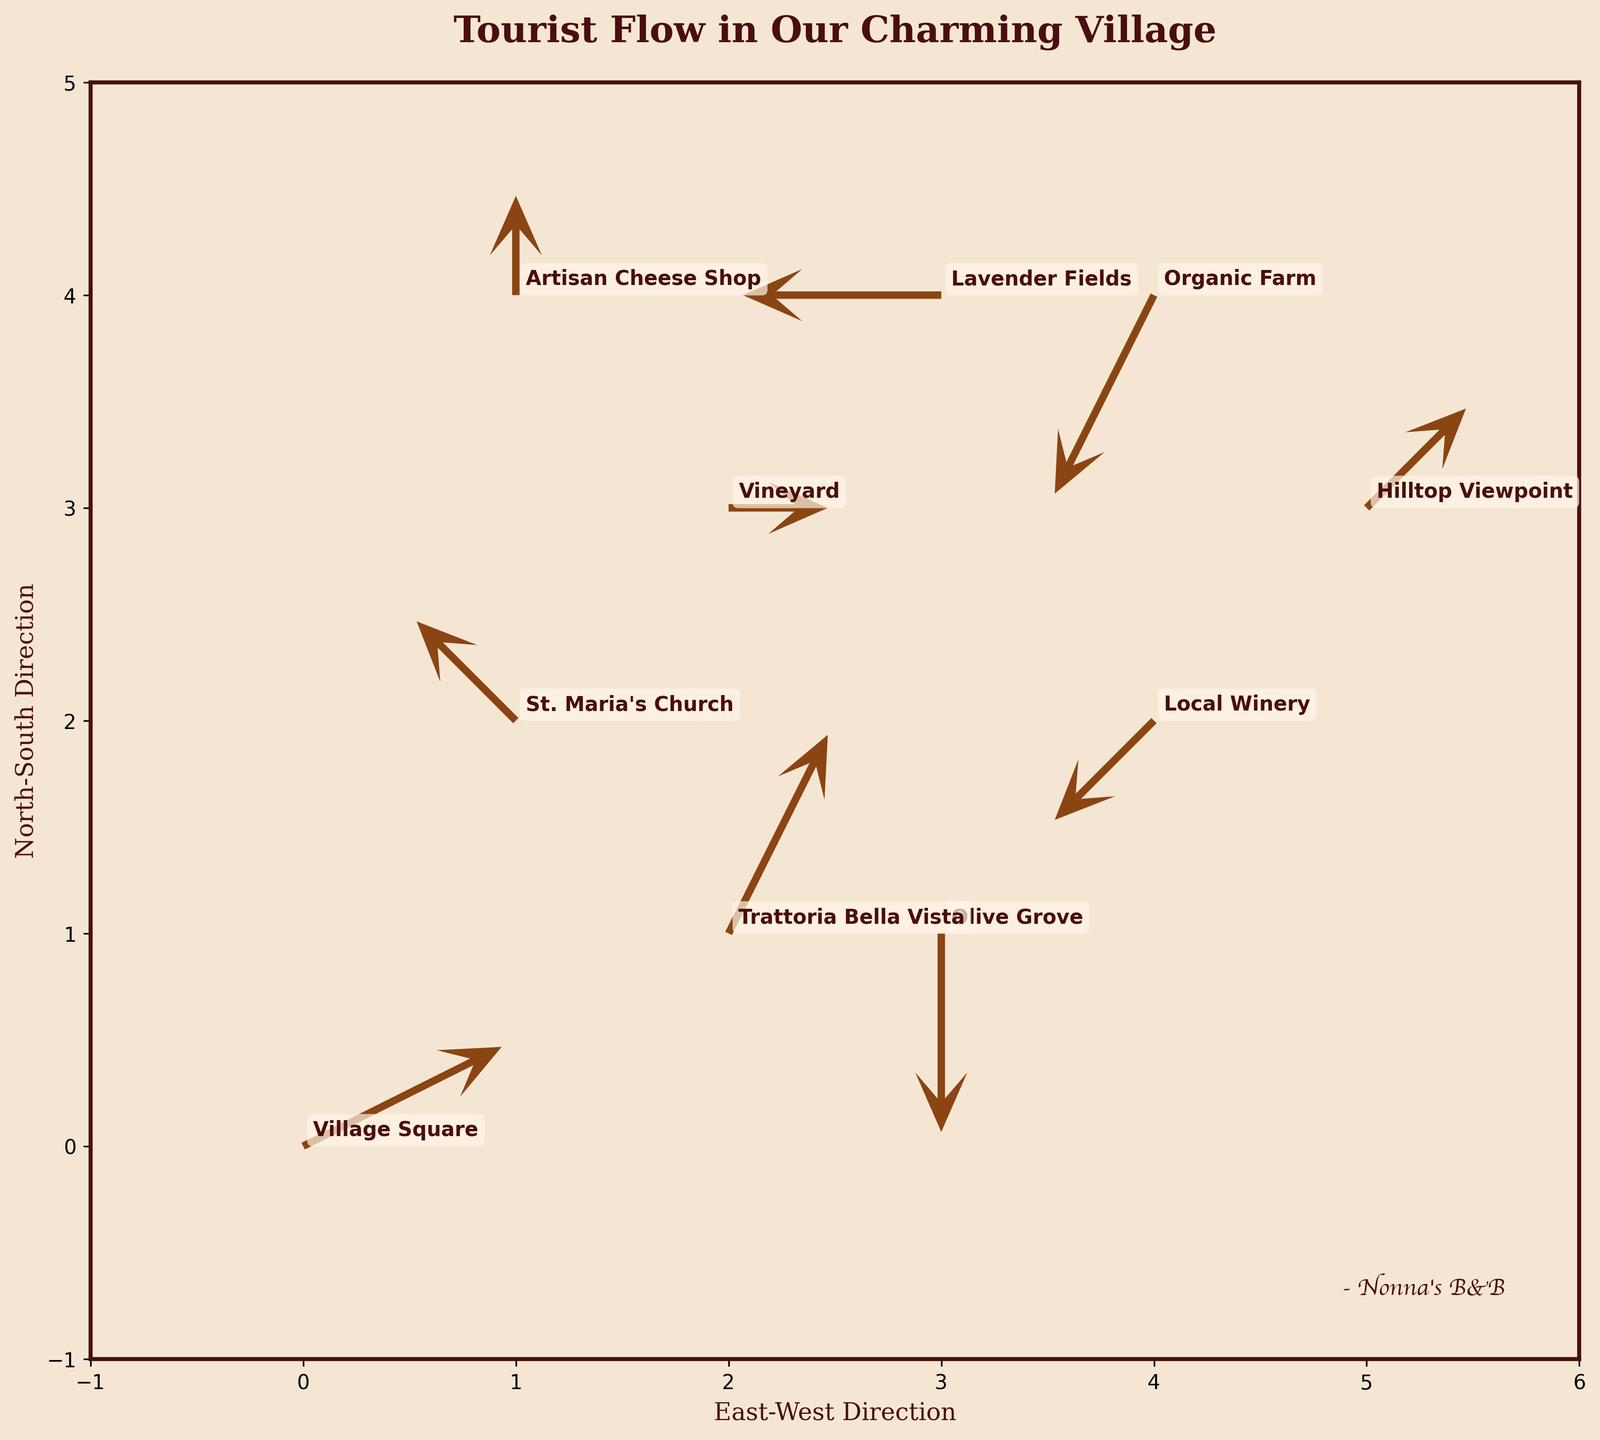What's the title of the figure? The title can be found at the top of the figure. It usually summarizes the main theme or subject of the visualization. Here, it is "Tourist Flow in Our Charming Village".
Answer: Tourist Flow in Our Charming Village What are the labels of the x and y axes? The labels are found along the axes. The x-axis is labeled "East-West Direction" and the y-axis is labeled "North-South Direction".
Answer: East-West Direction and North-South Direction How many attractions are shown in the figure? By counting the number of labeled points or quiver arrows, we can determine that there are 10 attractions labeled in the figure.
Answer: 10 Which attraction appears to have tourists moving in two different directions (inflow and outflow)? To find this, check the direction of the arrows at each attraction. The Local Winery and Olive Grove both have arrows pointing towards and away from them.
Answer: Local Winery and Olive Grove What is the general flow direction of tourists from the Village Square? We look at the arrow starting at the Village Square, which shows a movement towards the east and slightly to the south.
Answer: East and slightly south Which attraction is a destination for tourists coming from both the Village Square and the Vineyard? Tracing the arrows, we see that tourists from the Village Square head towards the Trattoria Bella Vista and the same is true for the tourists from the Vineyard.
Answer: Trattoria Bella Vista Which attractions have tourists moving towards the Organic Farm? The arrows show tourists moving from the Hilltop Viewpoint and the Vineyard towards the Organic Farm.
Answer: Hilltop Viewpoint and Vineyard Which attraction shows the highest net inflow of tourists? Net inflow can be measured by the sum of arrow components (u, v) towards the point. The Artisan Cheese Shop shows a consistent flow inwards from surrounding attractions.
Answer: Artisan Cheese Shop What is the total number of arrows pointing towards Olive Grove? By inspecting the figure, we can count the arrows that end at Olive Grove. There are none; only the arrow from Olive Grove points outwards.
Answer: 0 In which direction do tourists generally move from the St. Maria’s Church? Observe the quiver arrow at this location, indicating an outflow mostly towards the southeast direction.
Answer: Southeast 